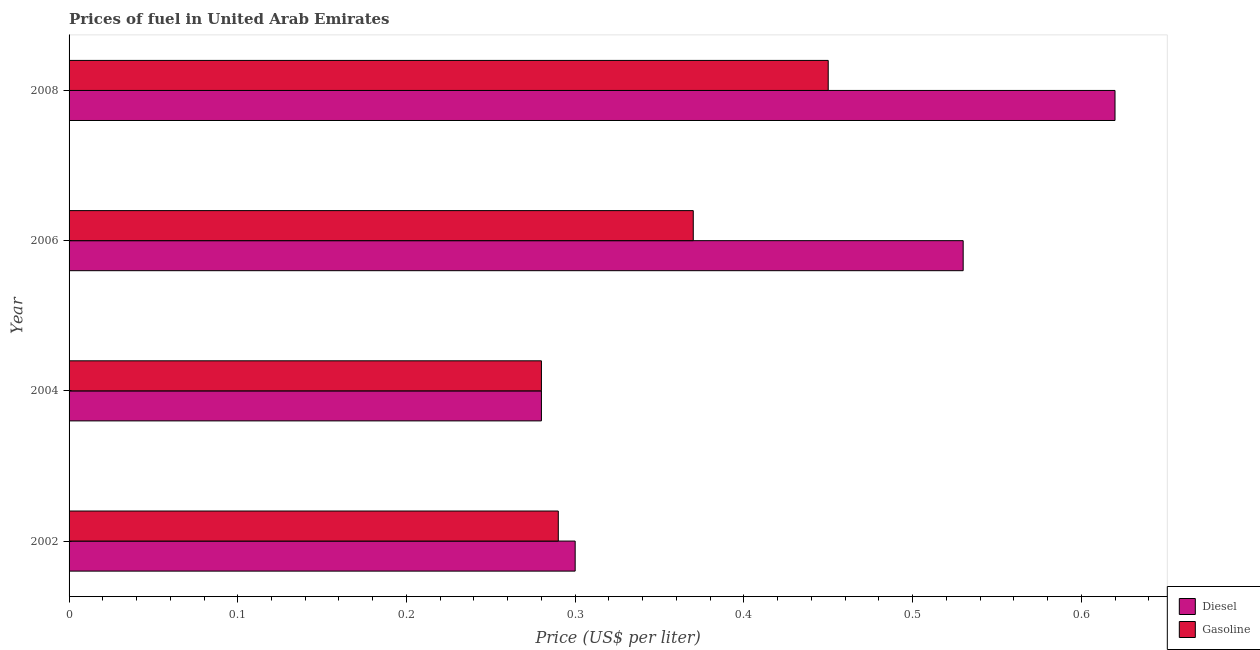How many different coloured bars are there?
Provide a short and direct response. 2. How many groups of bars are there?
Provide a succinct answer. 4. Are the number of bars per tick equal to the number of legend labels?
Keep it short and to the point. Yes. Are the number of bars on each tick of the Y-axis equal?
Your answer should be very brief. Yes. How many bars are there on the 3rd tick from the top?
Ensure brevity in your answer.  2. What is the gasoline price in 2004?
Your response must be concise. 0.28. Across all years, what is the maximum gasoline price?
Ensure brevity in your answer.  0.45. Across all years, what is the minimum diesel price?
Give a very brief answer. 0.28. In which year was the gasoline price minimum?
Ensure brevity in your answer.  2004. What is the total gasoline price in the graph?
Ensure brevity in your answer.  1.39. What is the difference between the gasoline price in 2004 and that in 2006?
Make the answer very short. -0.09. What is the difference between the diesel price in 2008 and the gasoline price in 2004?
Your answer should be very brief. 0.34. What is the average gasoline price per year?
Your answer should be compact. 0.35. In the year 2006, what is the difference between the gasoline price and diesel price?
Keep it short and to the point. -0.16. What is the ratio of the gasoline price in 2004 to that in 2006?
Your answer should be very brief. 0.76. Is the difference between the gasoline price in 2004 and 2008 greater than the difference between the diesel price in 2004 and 2008?
Make the answer very short. Yes. What is the difference between the highest and the second highest gasoline price?
Make the answer very short. 0.08. What is the difference between the highest and the lowest gasoline price?
Provide a succinct answer. 0.17. What does the 2nd bar from the top in 2004 represents?
Your answer should be compact. Diesel. What does the 2nd bar from the bottom in 2006 represents?
Your answer should be very brief. Gasoline. How many bars are there?
Provide a short and direct response. 8. What is the difference between two consecutive major ticks on the X-axis?
Your answer should be very brief. 0.1. What is the title of the graph?
Your response must be concise. Prices of fuel in United Arab Emirates. Does "Time to import" appear as one of the legend labels in the graph?
Give a very brief answer. No. What is the label or title of the X-axis?
Give a very brief answer. Price (US$ per liter). What is the Price (US$ per liter) of Diesel in 2002?
Your response must be concise. 0.3. What is the Price (US$ per liter) of Gasoline in 2002?
Provide a short and direct response. 0.29. What is the Price (US$ per liter) in Diesel in 2004?
Make the answer very short. 0.28. What is the Price (US$ per liter) of Gasoline in 2004?
Keep it short and to the point. 0.28. What is the Price (US$ per liter) of Diesel in 2006?
Your response must be concise. 0.53. What is the Price (US$ per liter) of Gasoline in 2006?
Ensure brevity in your answer.  0.37. What is the Price (US$ per liter) of Diesel in 2008?
Ensure brevity in your answer.  0.62. What is the Price (US$ per liter) in Gasoline in 2008?
Your answer should be compact. 0.45. Across all years, what is the maximum Price (US$ per liter) of Diesel?
Ensure brevity in your answer.  0.62. Across all years, what is the maximum Price (US$ per liter) of Gasoline?
Your response must be concise. 0.45. Across all years, what is the minimum Price (US$ per liter) of Diesel?
Offer a terse response. 0.28. Across all years, what is the minimum Price (US$ per liter) of Gasoline?
Make the answer very short. 0.28. What is the total Price (US$ per liter) in Diesel in the graph?
Keep it short and to the point. 1.73. What is the total Price (US$ per liter) in Gasoline in the graph?
Make the answer very short. 1.39. What is the difference between the Price (US$ per liter) of Diesel in 2002 and that in 2006?
Provide a short and direct response. -0.23. What is the difference between the Price (US$ per liter) of Gasoline in 2002 and that in 2006?
Give a very brief answer. -0.08. What is the difference between the Price (US$ per liter) in Diesel in 2002 and that in 2008?
Provide a succinct answer. -0.32. What is the difference between the Price (US$ per liter) of Gasoline in 2002 and that in 2008?
Ensure brevity in your answer.  -0.16. What is the difference between the Price (US$ per liter) of Diesel in 2004 and that in 2006?
Offer a very short reply. -0.25. What is the difference between the Price (US$ per liter) in Gasoline in 2004 and that in 2006?
Your answer should be very brief. -0.09. What is the difference between the Price (US$ per liter) in Diesel in 2004 and that in 2008?
Offer a very short reply. -0.34. What is the difference between the Price (US$ per liter) in Gasoline in 2004 and that in 2008?
Offer a terse response. -0.17. What is the difference between the Price (US$ per liter) in Diesel in 2006 and that in 2008?
Make the answer very short. -0.09. What is the difference between the Price (US$ per liter) in Gasoline in 2006 and that in 2008?
Make the answer very short. -0.08. What is the difference between the Price (US$ per liter) in Diesel in 2002 and the Price (US$ per liter) in Gasoline in 2006?
Offer a very short reply. -0.07. What is the difference between the Price (US$ per liter) in Diesel in 2004 and the Price (US$ per liter) in Gasoline in 2006?
Ensure brevity in your answer.  -0.09. What is the difference between the Price (US$ per liter) of Diesel in 2004 and the Price (US$ per liter) of Gasoline in 2008?
Make the answer very short. -0.17. What is the average Price (US$ per liter) in Diesel per year?
Your answer should be compact. 0.43. What is the average Price (US$ per liter) of Gasoline per year?
Provide a succinct answer. 0.35. In the year 2002, what is the difference between the Price (US$ per liter) in Diesel and Price (US$ per liter) in Gasoline?
Give a very brief answer. 0.01. In the year 2004, what is the difference between the Price (US$ per liter) in Diesel and Price (US$ per liter) in Gasoline?
Keep it short and to the point. 0. In the year 2006, what is the difference between the Price (US$ per liter) of Diesel and Price (US$ per liter) of Gasoline?
Your answer should be very brief. 0.16. In the year 2008, what is the difference between the Price (US$ per liter) of Diesel and Price (US$ per liter) of Gasoline?
Provide a succinct answer. 0.17. What is the ratio of the Price (US$ per liter) in Diesel in 2002 to that in 2004?
Provide a short and direct response. 1.07. What is the ratio of the Price (US$ per liter) in Gasoline in 2002 to that in 2004?
Ensure brevity in your answer.  1.04. What is the ratio of the Price (US$ per liter) of Diesel in 2002 to that in 2006?
Ensure brevity in your answer.  0.57. What is the ratio of the Price (US$ per liter) of Gasoline in 2002 to that in 2006?
Your answer should be very brief. 0.78. What is the ratio of the Price (US$ per liter) of Diesel in 2002 to that in 2008?
Your answer should be very brief. 0.48. What is the ratio of the Price (US$ per liter) of Gasoline in 2002 to that in 2008?
Offer a terse response. 0.64. What is the ratio of the Price (US$ per liter) in Diesel in 2004 to that in 2006?
Offer a very short reply. 0.53. What is the ratio of the Price (US$ per liter) in Gasoline in 2004 to that in 2006?
Your response must be concise. 0.76. What is the ratio of the Price (US$ per liter) of Diesel in 2004 to that in 2008?
Give a very brief answer. 0.45. What is the ratio of the Price (US$ per liter) in Gasoline in 2004 to that in 2008?
Keep it short and to the point. 0.62. What is the ratio of the Price (US$ per liter) of Diesel in 2006 to that in 2008?
Your answer should be compact. 0.85. What is the ratio of the Price (US$ per liter) in Gasoline in 2006 to that in 2008?
Provide a succinct answer. 0.82. What is the difference between the highest and the second highest Price (US$ per liter) of Diesel?
Provide a succinct answer. 0.09. What is the difference between the highest and the second highest Price (US$ per liter) in Gasoline?
Your response must be concise. 0.08. What is the difference between the highest and the lowest Price (US$ per liter) in Diesel?
Offer a terse response. 0.34. What is the difference between the highest and the lowest Price (US$ per liter) of Gasoline?
Give a very brief answer. 0.17. 